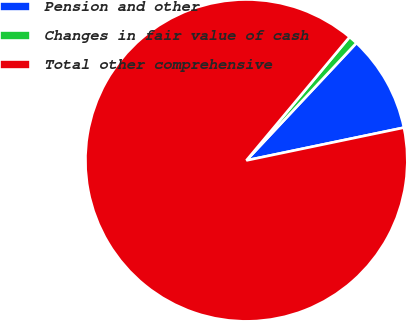Convert chart. <chart><loc_0><loc_0><loc_500><loc_500><pie_chart><fcel>Pension and other<fcel>Changes in fair value of cash<fcel>Total other comprehensive<nl><fcel>9.75%<fcel>0.9%<fcel>89.35%<nl></chart> 